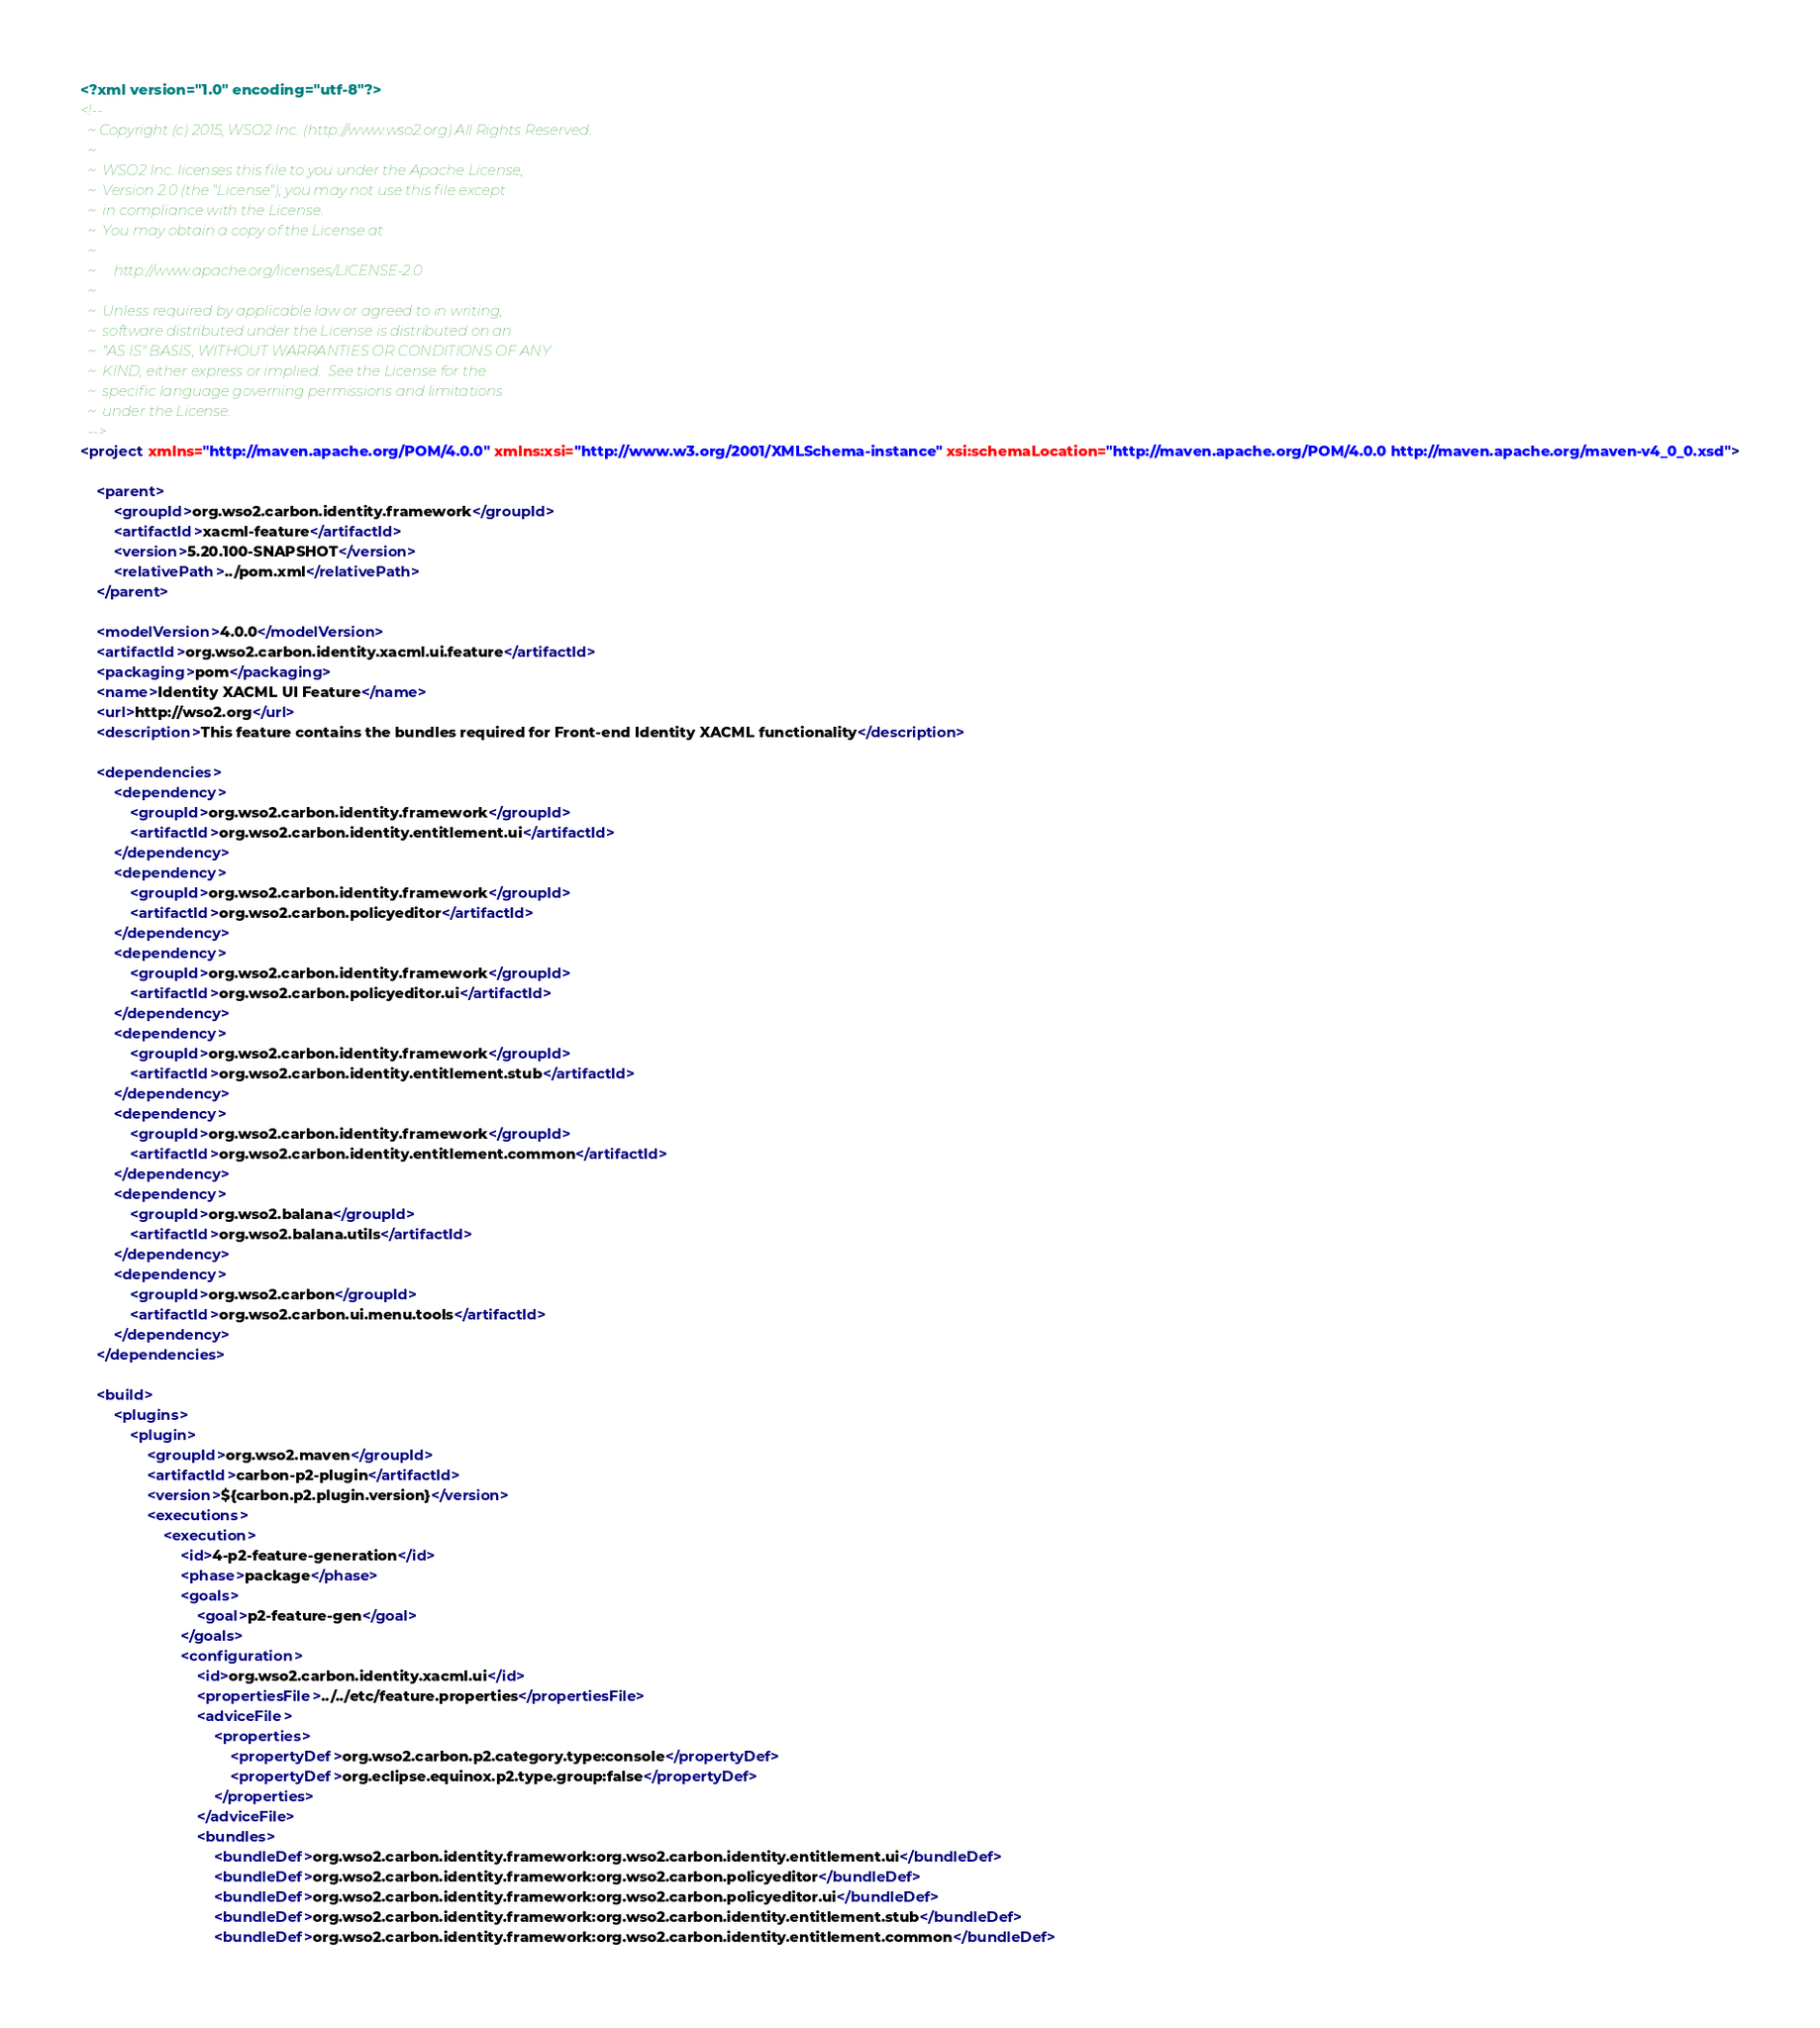<code> <loc_0><loc_0><loc_500><loc_500><_XML_><?xml version="1.0" encoding="utf-8"?>
<!--
  ~ Copyright (c) 2015, WSO2 Inc. (http://www.wso2.org) All Rights Reserved.
  ~
  ~  WSO2 Inc. licenses this file to you under the Apache License,
  ~  Version 2.0 (the "License"); you may not use this file except
  ~  in compliance with the License.
  ~  You may obtain a copy of the License at
  ~
  ~     http://www.apache.org/licenses/LICENSE-2.0
  ~
  ~  Unless required by applicable law or agreed to in writing,
  ~  software distributed under the License is distributed on an
  ~  "AS IS" BASIS, WITHOUT WARRANTIES OR CONDITIONS OF ANY
  ~  KIND, either express or implied.  See the License for the
  ~  specific language governing permissions and limitations
  ~  under the License.
  -->
<project xmlns="http://maven.apache.org/POM/4.0.0" xmlns:xsi="http://www.w3.org/2001/XMLSchema-instance" xsi:schemaLocation="http://maven.apache.org/POM/4.0.0 http://maven.apache.org/maven-v4_0_0.xsd">

    <parent>
        <groupId>org.wso2.carbon.identity.framework</groupId>
        <artifactId>xacml-feature</artifactId>
        <version>5.20.100-SNAPSHOT</version>
        <relativePath>../pom.xml</relativePath>
    </parent>

    <modelVersion>4.0.0</modelVersion>
    <artifactId>org.wso2.carbon.identity.xacml.ui.feature</artifactId>
    <packaging>pom</packaging>
    <name>Identity XACML UI Feature</name>
    <url>http://wso2.org</url>
    <description>This feature contains the bundles required for Front-end Identity XACML functionality</description>

    <dependencies>
        <dependency>
            <groupId>org.wso2.carbon.identity.framework</groupId>
            <artifactId>org.wso2.carbon.identity.entitlement.ui</artifactId>
        </dependency>
        <dependency>
            <groupId>org.wso2.carbon.identity.framework</groupId>
            <artifactId>org.wso2.carbon.policyeditor</artifactId>
        </dependency>
        <dependency>
            <groupId>org.wso2.carbon.identity.framework</groupId>
            <artifactId>org.wso2.carbon.policyeditor.ui</artifactId>
        </dependency>
        <dependency>
            <groupId>org.wso2.carbon.identity.framework</groupId>
            <artifactId>org.wso2.carbon.identity.entitlement.stub</artifactId>
        </dependency>
        <dependency>
            <groupId>org.wso2.carbon.identity.framework</groupId>
            <artifactId>org.wso2.carbon.identity.entitlement.common</artifactId>
        </dependency>
        <dependency>
            <groupId>org.wso2.balana</groupId>
            <artifactId>org.wso2.balana.utils</artifactId>
        </dependency>
        <dependency>
            <groupId>org.wso2.carbon</groupId>
            <artifactId>org.wso2.carbon.ui.menu.tools</artifactId>
        </dependency>
    </dependencies>

    <build>
        <plugins>
            <plugin>
                <groupId>org.wso2.maven</groupId>
                <artifactId>carbon-p2-plugin</artifactId>
                <version>${carbon.p2.plugin.version}</version>
                <executions>
                    <execution>
                        <id>4-p2-feature-generation</id>
                        <phase>package</phase>
                        <goals>
                            <goal>p2-feature-gen</goal>
                        </goals>
                        <configuration>
                            <id>org.wso2.carbon.identity.xacml.ui</id>
                            <propertiesFile>../../etc/feature.properties</propertiesFile>
                            <adviceFile>
                                <properties>
                                    <propertyDef>org.wso2.carbon.p2.category.type:console</propertyDef>
                                    <propertyDef>org.eclipse.equinox.p2.type.group:false</propertyDef>
                                </properties>
                            </adviceFile>
                            <bundles>
                                <bundleDef>org.wso2.carbon.identity.framework:org.wso2.carbon.identity.entitlement.ui</bundleDef>
                                <bundleDef>org.wso2.carbon.identity.framework:org.wso2.carbon.policyeditor</bundleDef>
                                <bundleDef>org.wso2.carbon.identity.framework:org.wso2.carbon.policyeditor.ui</bundleDef>
                                <bundleDef>org.wso2.carbon.identity.framework:org.wso2.carbon.identity.entitlement.stub</bundleDef>
                                <bundleDef>org.wso2.carbon.identity.framework:org.wso2.carbon.identity.entitlement.common</bundleDef></code> 